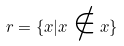<formula> <loc_0><loc_0><loc_500><loc_500>r = \{ x | x \notin x \}</formula> 